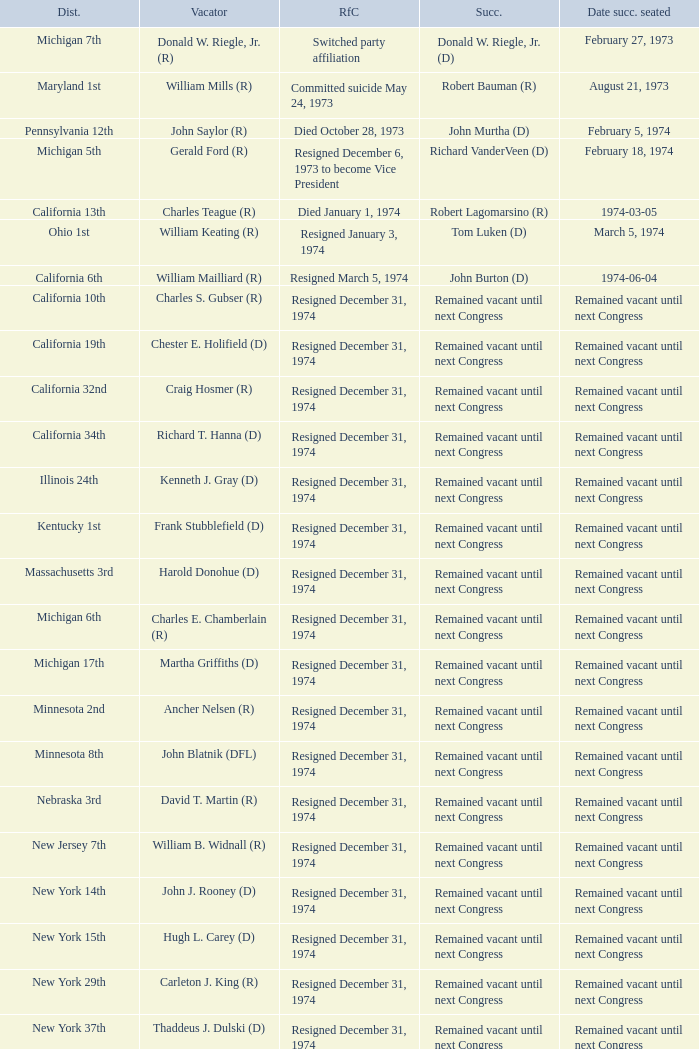Can you give me this table as a dict? {'header': ['Dist.', 'Vacator', 'RfC', 'Succ.', 'Date succ. seated'], 'rows': [['Michigan 7th', 'Donald W. Riegle, Jr. (R)', 'Switched party affiliation', 'Donald W. Riegle, Jr. (D)', 'February 27, 1973'], ['Maryland 1st', 'William Mills (R)', 'Committed suicide May 24, 1973', 'Robert Bauman (R)', 'August 21, 1973'], ['Pennsylvania 12th', 'John Saylor (R)', 'Died October 28, 1973', 'John Murtha (D)', 'February 5, 1974'], ['Michigan 5th', 'Gerald Ford (R)', 'Resigned December 6, 1973 to become Vice President', 'Richard VanderVeen (D)', 'February 18, 1974'], ['California 13th', 'Charles Teague (R)', 'Died January 1, 1974', 'Robert Lagomarsino (R)', '1974-03-05'], ['Ohio 1st', 'William Keating (R)', 'Resigned January 3, 1974', 'Tom Luken (D)', 'March 5, 1974'], ['California 6th', 'William Mailliard (R)', 'Resigned March 5, 1974', 'John Burton (D)', '1974-06-04'], ['California 10th', 'Charles S. Gubser (R)', 'Resigned December 31, 1974', 'Remained vacant until next Congress', 'Remained vacant until next Congress'], ['California 19th', 'Chester E. Holifield (D)', 'Resigned December 31, 1974', 'Remained vacant until next Congress', 'Remained vacant until next Congress'], ['California 32nd', 'Craig Hosmer (R)', 'Resigned December 31, 1974', 'Remained vacant until next Congress', 'Remained vacant until next Congress'], ['California 34th', 'Richard T. Hanna (D)', 'Resigned December 31, 1974', 'Remained vacant until next Congress', 'Remained vacant until next Congress'], ['Illinois 24th', 'Kenneth J. Gray (D)', 'Resigned December 31, 1974', 'Remained vacant until next Congress', 'Remained vacant until next Congress'], ['Kentucky 1st', 'Frank Stubblefield (D)', 'Resigned December 31, 1974', 'Remained vacant until next Congress', 'Remained vacant until next Congress'], ['Massachusetts 3rd', 'Harold Donohue (D)', 'Resigned December 31, 1974', 'Remained vacant until next Congress', 'Remained vacant until next Congress'], ['Michigan 6th', 'Charles E. Chamberlain (R)', 'Resigned December 31, 1974', 'Remained vacant until next Congress', 'Remained vacant until next Congress'], ['Michigan 17th', 'Martha Griffiths (D)', 'Resigned December 31, 1974', 'Remained vacant until next Congress', 'Remained vacant until next Congress'], ['Minnesota 2nd', 'Ancher Nelsen (R)', 'Resigned December 31, 1974', 'Remained vacant until next Congress', 'Remained vacant until next Congress'], ['Minnesota 8th', 'John Blatnik (DFL)', 'Resigned December 31, 1974', 'Remained vacant until next Congress', 'Remained vacant until next Congress'], ['Nebraska 3rd', 'David T. Martin (R)', 'Resigned December 31, 1974', 'Remained vacant until next Congress', 'Remained vacant until next Congress'], ['New Jersey 7th', 'William B. Widnall (R)', 'Resigned December 31, 1974', 'Remained vacant until next Congress', 'Remained vacant until next Congress'], ['New York 14th', 'John J. Rooney (D)', 'Resigned December 31, 1974', 'Remained vacant until next Congress', 'Remained vacant until next Congress'], ['New York 15th', 'Hugh L. Carey (D)', 'Resigned December 31, 1974', 'Remained vacant until next Congress', 'Remained vacant until next Congress'], ['New York 29th', 'Carleton J. King (R)', 'Resigned December 31, 1974', 'Remained vacant until next Congress', 'Remained vacant until next Congress'], ['New York 37th', 'Thaddeus J. Dulski (D)', 'Resigned December 31, 1974', 'Remained vacant until next Congress', 'Remained vacant until next Congress'], ['Ohio 23rd', 'William Minshall (R)', 'Resigned December 31, 1974', 'Remained vacant until next Congress', 'Remained vacant until next Congress'], ['Oregon 3rd', 'Edith S. Green (D)', 'Resigned December 31, 1974', 'Remained vacant until next Congress', 'Remained vacant until next Congress'], ['Pennsylvania 25th', 'Frank M. Clark (D)', 'Resigned December 31, 1974', 'Remained vacant until next Congress', 'Remained vacant until next Congress'], ['South Carolina 3rd', 'W.J. Bryan Dorn (D)', 'Resigned December 31, 1974', 'Remained vacant until next Congress', 'Remained vacant until next Congress'], ['South Carolina 5th', 'Thomas S. Gettys (D)', 'Resigned December 31, 1974', 'Remained vacant until next Congress', 'Remained vacant until next Congress'], ['Texas 21st', 'O. C. Fisher (D)', 'Resigned December 31, 1974', 'Remained vacant until next Congress', 'Remained vacant until next Congress'], ['Washington 3rd', 'Julia B. Hansen (D)', 'Resigned December 31, 1974', 'Remained vacant until next Congress', 'Remained vacant until next Congress'], ['Wisconsin 3rd', 'Vernon W. Thomson (R)', 'Resigned December 31, 1974', 'Remained vacant until next Congress', 'Remained vacant until next Congress']]} When was the successor seated when the district was California 10th? Remained vacant until next Congress. 